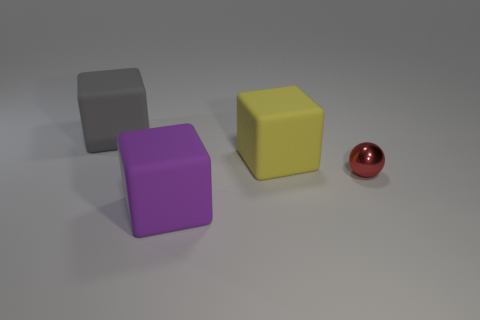Are there more big gray matte cubes that are on the left side of the large gray matte thing than large rubber cubes that are to the right of the small ball?
Provide a short and direct response. No. What number of other things are there of the same size as the purple block?
Provide a succinct answer. 2. There is a gray matte thing; is its shape the same as the thing that is in front of the red sphere?
Your answer should be compact. Yes. How many matte things are either brown balls or big gray cubes?
Provide a succinct answer. 1. Is there another tiny ball of the same color as the metallic ball?
Offer a very short reply. No. Is there a large red matte cube?
Make the answer very short. No. Do the small metal object and the gray rubber thing have the same shape?
Offer a very short reply. No. What number of large objects are either balls or rubber cubes?
Keep it short and to the point. 3. The tiny shiny object has what color?
Provide a succinct answer. Red. The small red metal object that is behind the matte cube that is in front of the yellow rubber block is what shape?
Make the answer very short. Sphere. 